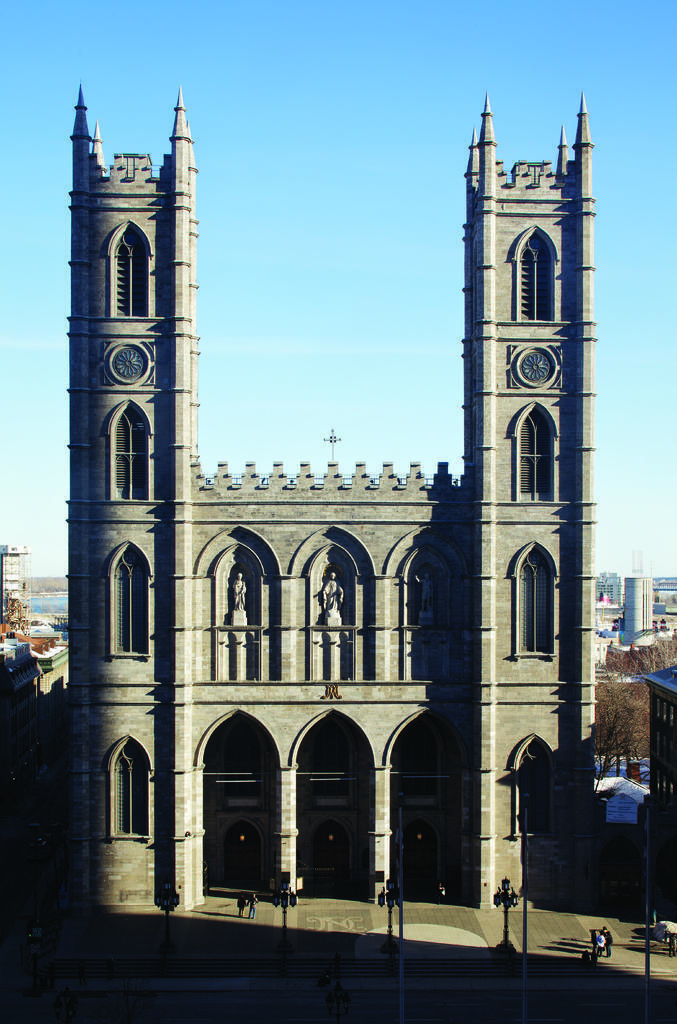Could you give a brief overview of what you see in this image? In this picture I can observe a monument in the middle of the picture. In the background I can observe sky. 